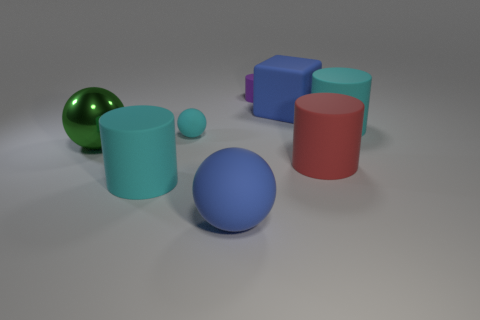Which color appears most frequently among the objects? The color blue appears to be the most frequent among the objects. There is a large blue sphere and a smaller blue cylinder situated toward the bottom left of the image. 